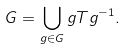Convert formula to latex. <formula><loc_0><loc_0><loc_500><loc_500>G = \bigcup _ { g \in G } g T g ^ { - 1 } .</formula> 